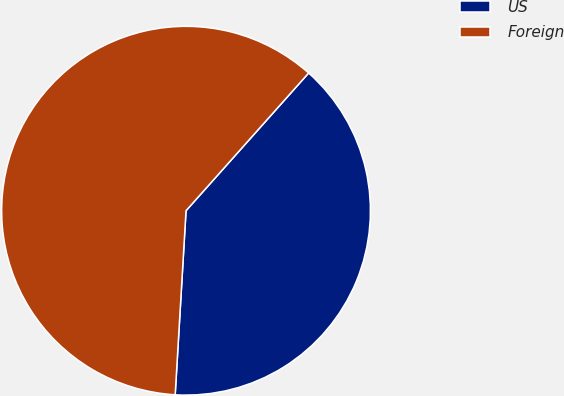<chart> <loc_0><loc_0><loc_500><loc_500><pie_chart><fcel>US<fcel>Foreign<nl><fcel>39.36%<fcel>60.64%<nl></chart> 